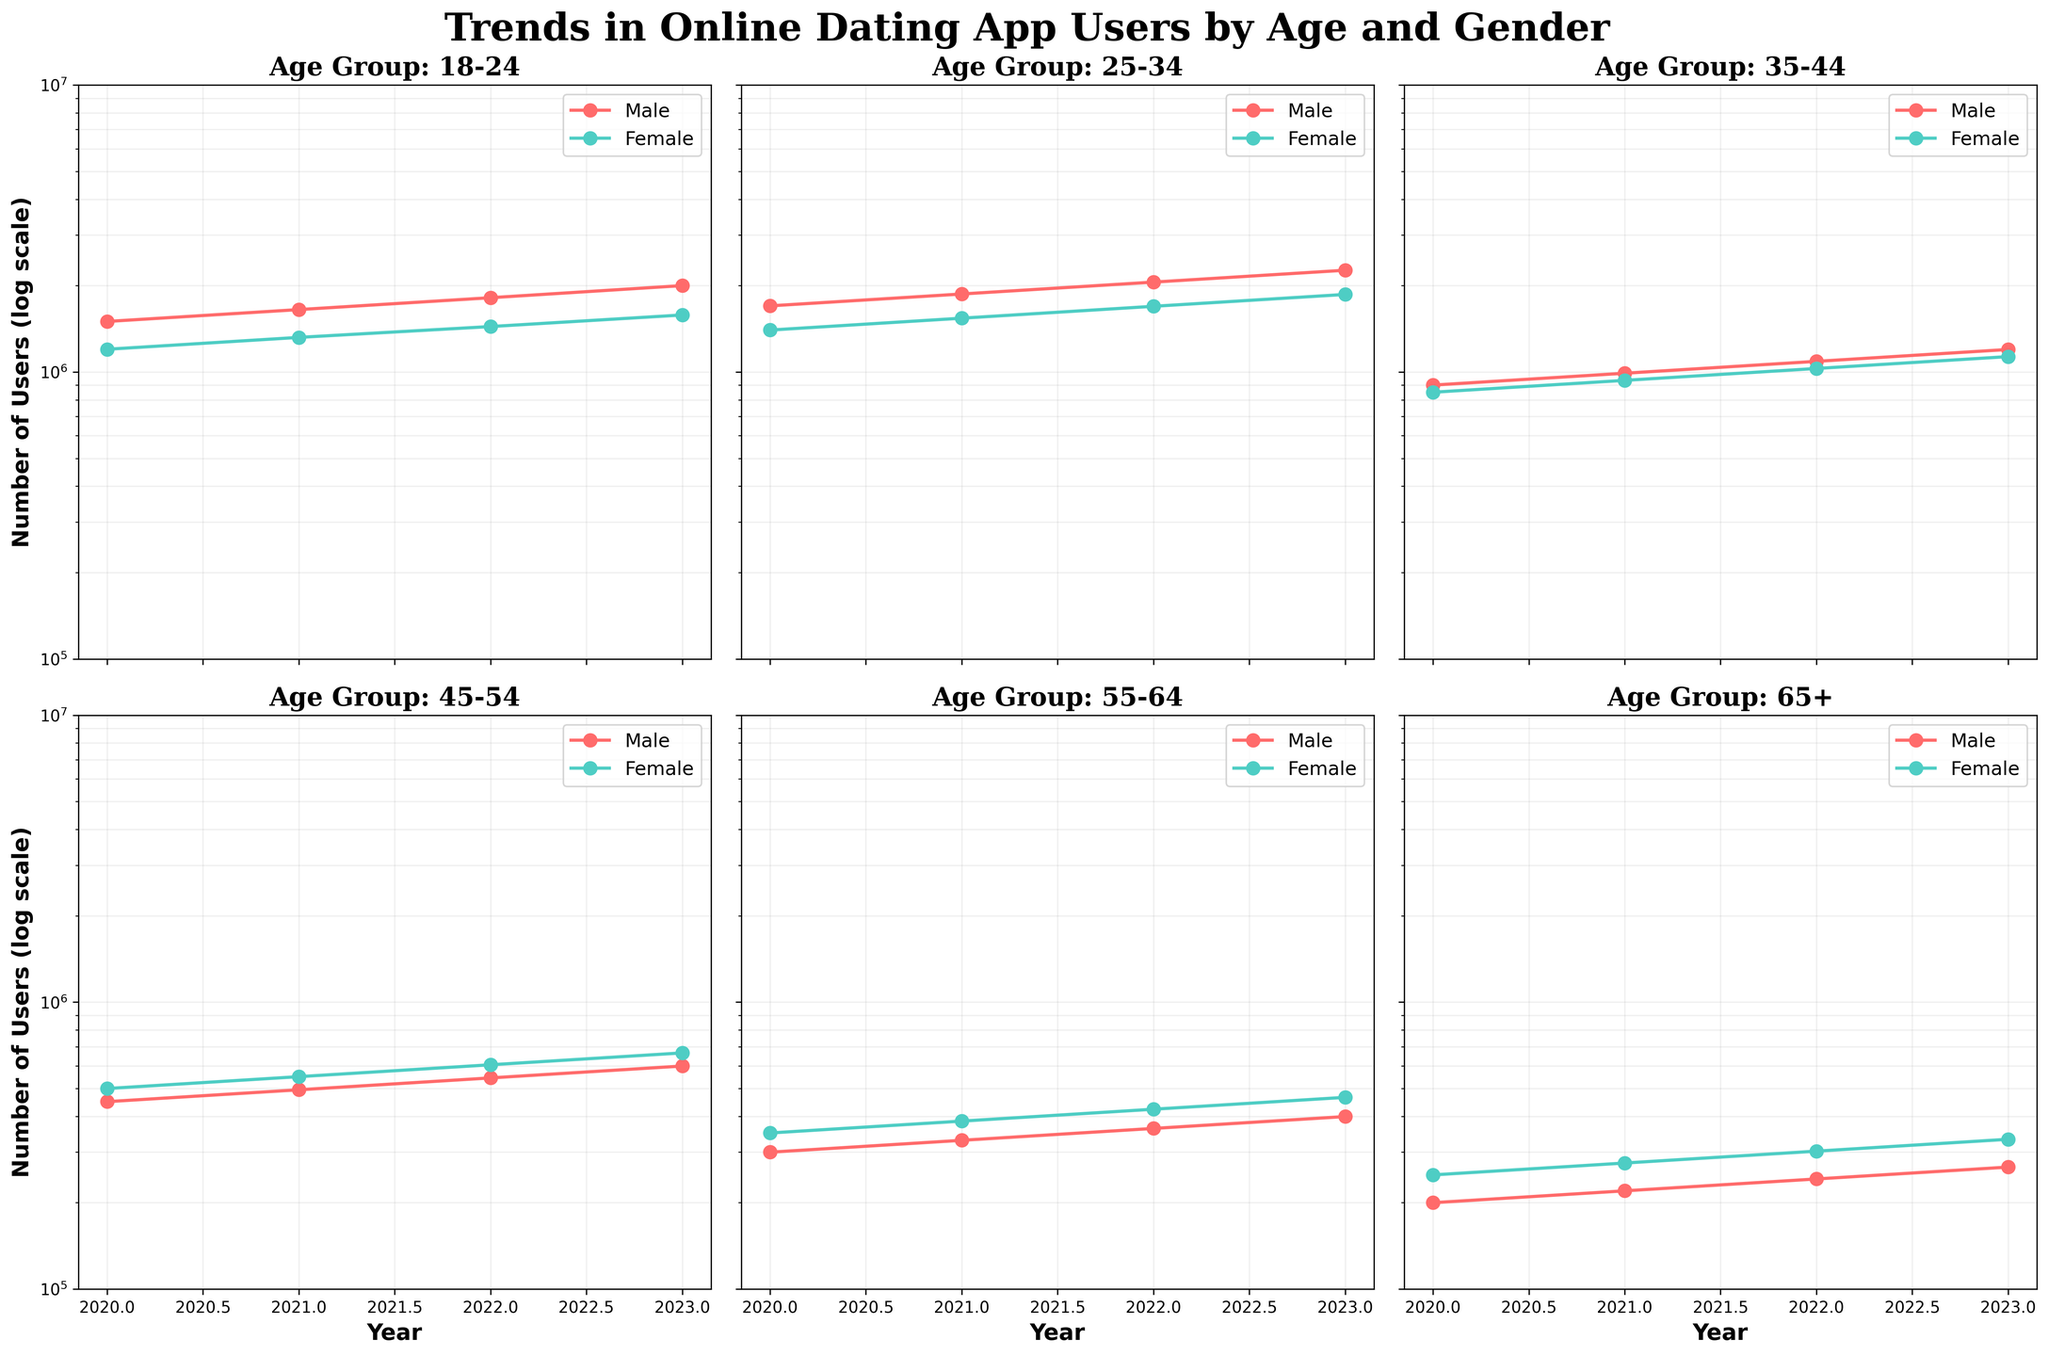Which age group has the highest number of users for both genders in 2023? To determine this, look for the highest data points in 2023 for both male and female users across all age groups. The 25-34 age group has the highest value with 2,262,700 male users and 1,863,400 female users.
Answer: 25-34 How do the numbers of male and female users change from 2022 to 2023 in the 45-54 age group? For the 45-54 age group, calculate the difference between the numbers of users in 2022 and 2023 for both genders. For males: 598,950 - 544,500 = 54,450. For females: 665,500 - 605,000 = 60,500.
Answer: Increase by 54,450 (Male), Increase by 60,500 (Female) Which gender shows a steeper rise in the number of users in the 18-24 age group over these years? Assess the slope of the increase by comparing the starting and ending points from 2020 to 2023 for both genders. For males: 2,000,000 - 1,500,000 = 500,000. For females: 1,580,000 - 1,200,000 = 380,000.
Answer: Male What is the total number of users in the 35-44 age group in 2021 for both genders combined? Add the male and female users in 2021 for the 35-44 age group. 990,000 (Male) + 935,000 (Female) = 1,925,000.
Answer: 1,925,000 In which year did the 55-64 age group males surpass 300,000 users? Identify the first year where the male users in the 55-64 age group exceed 300,000 by examining the data values. The number surpassed 300,000 in 2021.
Answer: 2021 What was the percentage increase in female users from 2020 to 2021 in the 25-34 age group? Calculate the percentage increase using the formula ((New Value - Old Value) / Old Value) * 100. ((1,540,000 - 1,400,000) / 1,400,000) * 100 = 10%.
Answer: 10% Which age group shows the smallest difference in the number of users between genders in 2023? Determine the difference between male and female users in 2023 for each age group and identify the smallest. The smallest difference is in the 65+ age group: 332,750 (Female) - 266,200 (Male) = 66,550.
Answer: 65+ How has the number of male users in the 65+ age group changed from 2020 to 2023? Note the difference in the number of male users in the 65+ age group from 2020 to 2023. 266,200 - 200,000 = 66,200.
Answer: Increase by 66,200 In which age group did female users see a more gradual increase over time? Compare the slopes of the lines for female users across all age groups by examining how the values change year over year. The increase in the 35-44 age group: 935,000 (2021) - 850,000 (2020), 1,028,500 (2022) - 935,000 (2021), and 1,131,350 (2023) - 1,028,500 (2022), shows the smallest incremental changes.
Answer: 35-44 Across all age groups, which gender has higher user numbers consistently in 2023? Compare the numbers of male and female users for each age group in 2023. Males have higher user numbers across all published age groups in 2023.
Answer: Male 